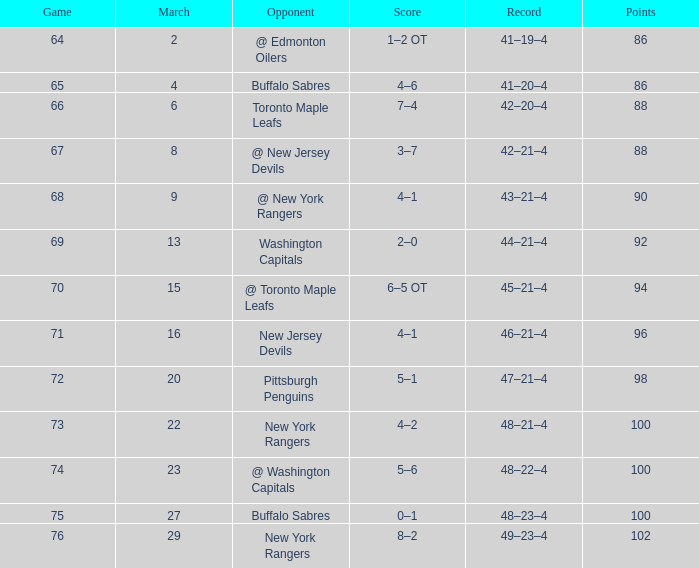Which Score has a March larger than 15, and Points larger than 96, and a Game smaller than 76, and an Opponent of @ washington capitals? 5–6. 